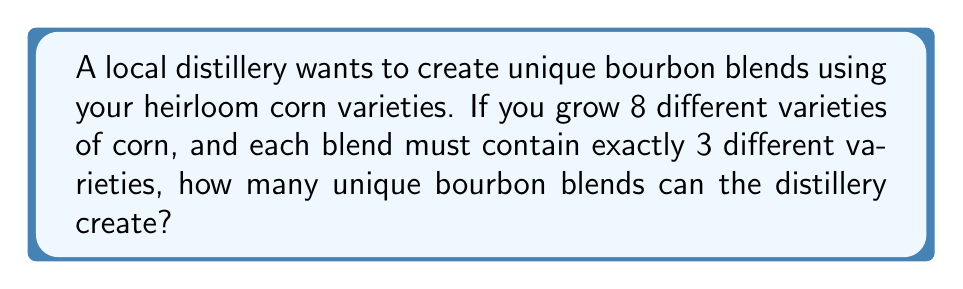Can you answer this question? To solve this problem, we need to use the combination formula. We're selecting 3 corn varieties out of 8, where the order doesn't matter (since we're just interested in the unique blends, not the order of selection).

The formula for combinations is:

$$ C(n,r) = \binom{n}{r} = \frac{n!}{r!(n-r)!} $$

Where:
$n$ is the total number of items to choose from (in this case, 8 corn varieties)
$r$ is the number of items being chosen (in this case, 3 varieties for each blend)

Let's plug in our values:

$$ C(8,3) = \binom{8}{3} = \frac{8!}{3!(8-3)!} = \frac{8!}{3!5!} $$

Now, let's calculate this step-by-step:

1) $8! = 8 \times 7 \times 6 \times 5!$
2) $3! = 3 \times 2 \times 1 = 6$

Substituting these values:

$$ \frac{8 \times 7 \times 6 \times 5!}{6 \times 5!} $$

The $5!$ cancels out in the numerator and denominator:

$$ \frac{8 \times 7 \times 6}{6} = 8 \times 7 = 56 $$

Therefore, the distillery can create 56 unique bourbon blends using your heirloom corn varieties.
Answer: 56 